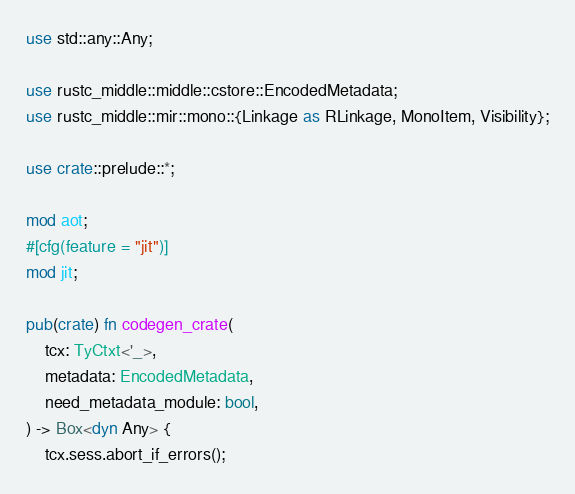Convert code to text. <code><loc_0><loc_0><loc_500><loc_500><_Rust_>use std::any::Any;

use rustc_middle::middle::cstore::EncodedMetadata;
use rustc_middle::mir::mono::{Linkage as RLinkage, MonoItem, Visibility};

use crate::prelude::*;

mod aot;
#[cfg(feature = "jit")]
mod jit;

pub(crate) fn codegen_crate(
    tcx: TyCtxt<'_>,
    metadata: EncodedMetadata,
    need_metadata_module: bool,
) -> Box<dyn Any> {
    tcx.sess.abort_if_errors();
</code> 